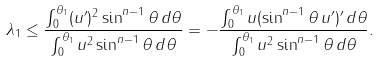<formula> <loc_0><loc_0><loc_500><loc_500>\lambda _ { 1 } \leq \frac { \int _ { 0 } ^ { \theta _ { 1 } } ( u ^ { \prime } ) ^ { 2 } \sin ^ { n - 1 } \theta \, d \theta } { \int _ { 0 } ^ { \theta _ { 1 } } u ^ { 2 } \sin ^ { n - 1 } \theta \, d \theta } = - \frac { \int _ { 0 } ^ { \theta _ { 1 } } u ( \sin ^ { n - 1 } \theta \, u ^ { \prime } ) ^ { \prime } \, d \theta } { \int _ { 0 } ^ { \theta _ { 1 } } u ^ { 2 } \sin ^ { n - 1 } \theta \, d \theta } .</formula> 